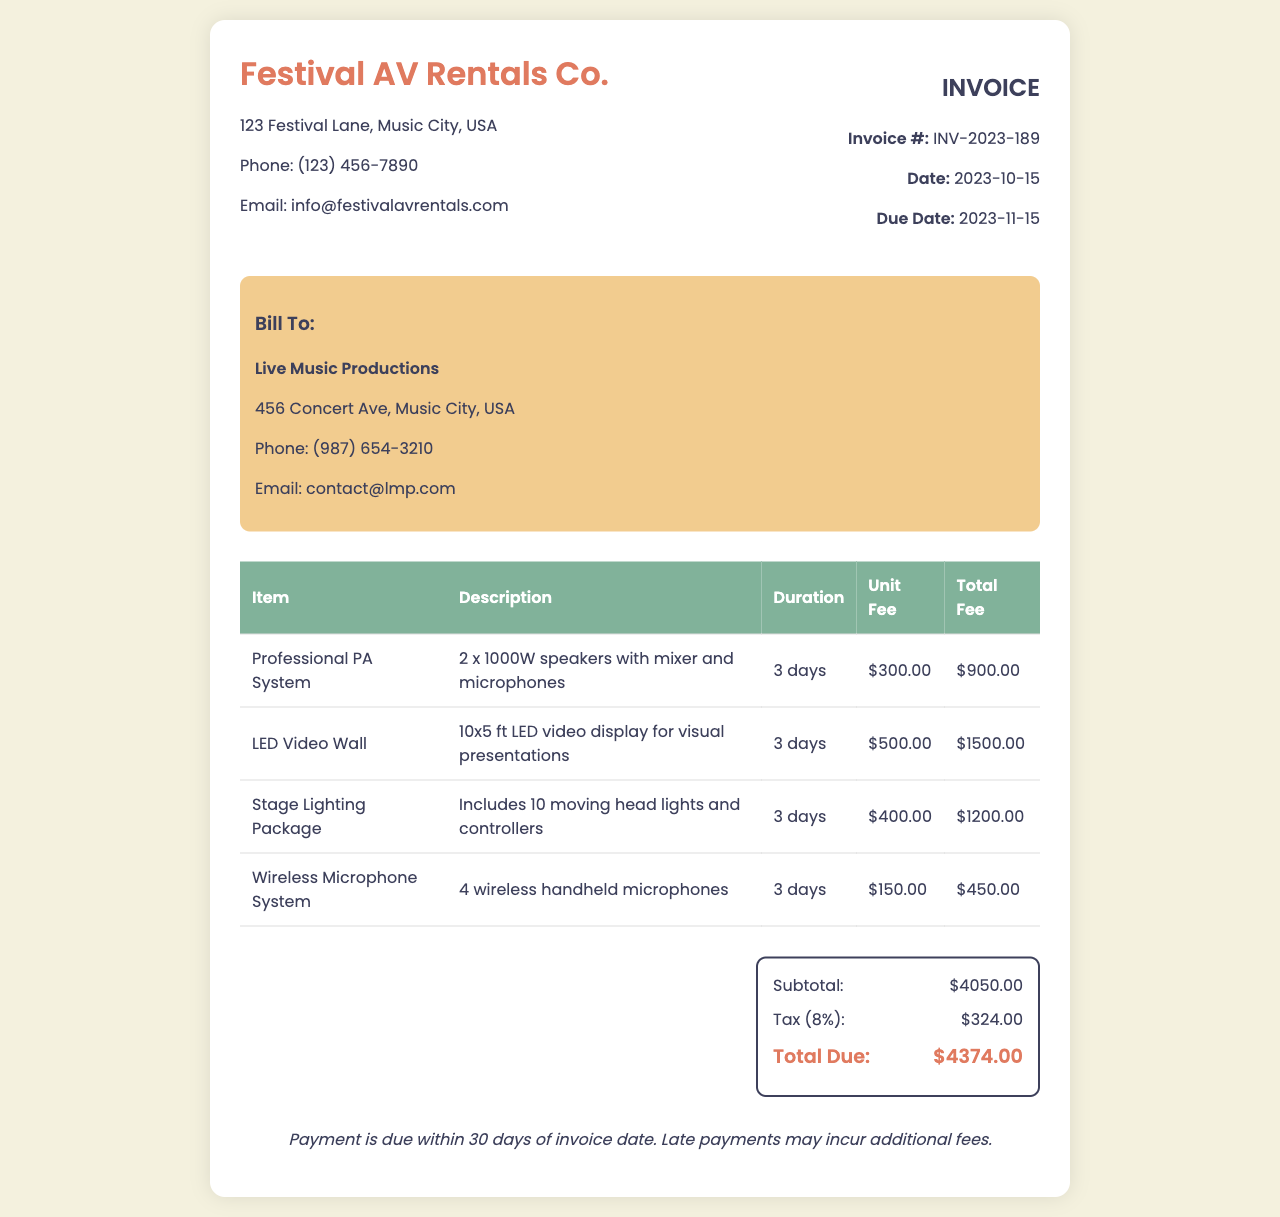What is the invoice number? The invoice number is located in the invoice info section, labeled as "Invoice #".
Answer: INV-2023-189 What is the total fee for the LED Video Wall? The total fee for the LED Video Wall is specified in the table under "Total Fee".
Answer: $1500.00 How many days was the Professional PA System rented? The duration for which the Professional PA System was rented is detailed in the duration column of the table.
Answer: 3 days What is the tax percentage applied to the subtotal? The tax percentage can be seen in the summary, specifically in the "Tax" line.
Answer: 8% Who is billed for the services? The billing section directly indicates the client being billed.
Answer: Live Music Productions What is the subtotal amount before tax? The subtotal amount is explicitly stated in the summary.
Answer: $4050.00 What is the due date for the payment? The due date for payment is mentioned in the invoice information section.
Answer: 2023-11-15 How many wireless microphones are included in the rental? The number of microphones is included in the description of the Wireless Microphone System in the table.
Answer: 4 What is the total amount due? The total amount due is clearly listed at the end of the summary section.
Answer: $4374.00 